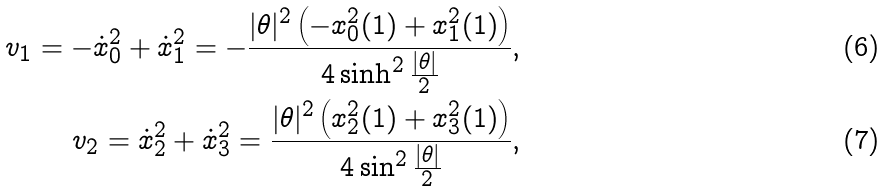Convert formula to latex. <formula><loc_0><loc_0><loc_500><loc_500>v _ { 1 } = - \dot { x } _ { 0 } ^ { 2 } + \dot { x } _ { 1 } ^ { 2 } = - \frac { | \theta | ^ { 2 } \left ( - x _ { 0 } ^ { 2 } ( 1 ) + x _ { 1 } ^ { 2 } ( 1 ) \right ) } { 4 \sinh ^ { 2 } \frac { | \theta | } { 2 } } , \\ v _ { 2 } = \dot { x } _ { 2 } ^ { 2 } + \dot { x } _ { 3 } ^ { 2 } = \frac { | \theta | ^ { 2 } \left ( x _ { 2 } ^ { 2 } ( 1 ) + x _ { 3 } ^ { 2 } ( 1 ) \right ) } { 4 \sin ^ { 2 } \frac { | \theta | } { 2 } } ,</formula> 